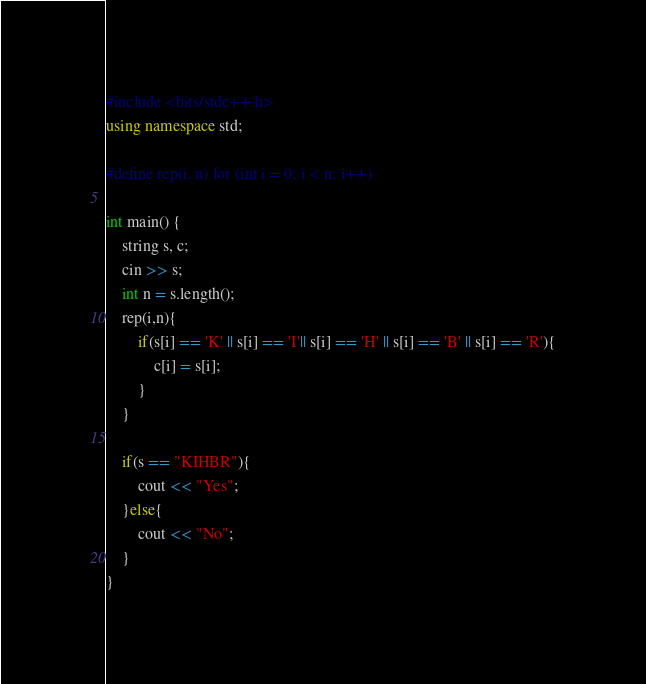Convert code to text. <code><loc_0><loc_0><loc_500><loc_500><_C++_>#include <bits/stdc++.h>
using namespace std;

#define rep(i, n) for (int i = 0; i < n; i++)

int main() {
    string s, c;
    cin >> s;
    int n = s.length();
    rep(i,n){
        if(s[i] == 'K' || s[i] == 'I'|| s[i] == 'H' || s[i] == 'B' || s[i] == 'R'){
            c[i] = s[i];
        }
    }

    if(s == "KIHBR"){
        cout << "Yes";
    }else{
        cout << "No";
    }
}

</code> 